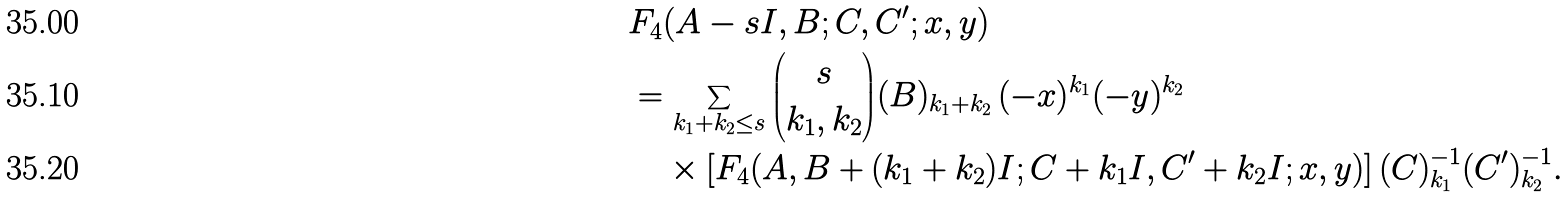<formula> <loc_0><loc_0><loc_500><loc_500>& F _ { 4 } ( A - s I , B ; C , C ^ { \prime } ; x , y ) \\ & = \sum _ { k _ { 1 } + k _ { 2 } \leq s } { s \choose k _ { 1 } , k _ { 2 } } { ( B ) _ { k _ { 1 } + k _ { 2 } } } \, ( - x ) ^ { k _ { 1 } } ( - y ) ^ { k _ { 2 } } \, \\ & \quad \times \left [ { F _ { 4 } } ( A , B + ( k _ { 1 } + k _ { 2 } ) I ; C + k _ { 1 } I , C ^ { \prime } + k _ { 2 } I ; x , y ) \right ] { ( C ) ^ { - 1 } _ { k _ { 1 } } ( C ^ { \prime } ) ^ { - 1 } _ { k _ { 2 } } } .</formula> 